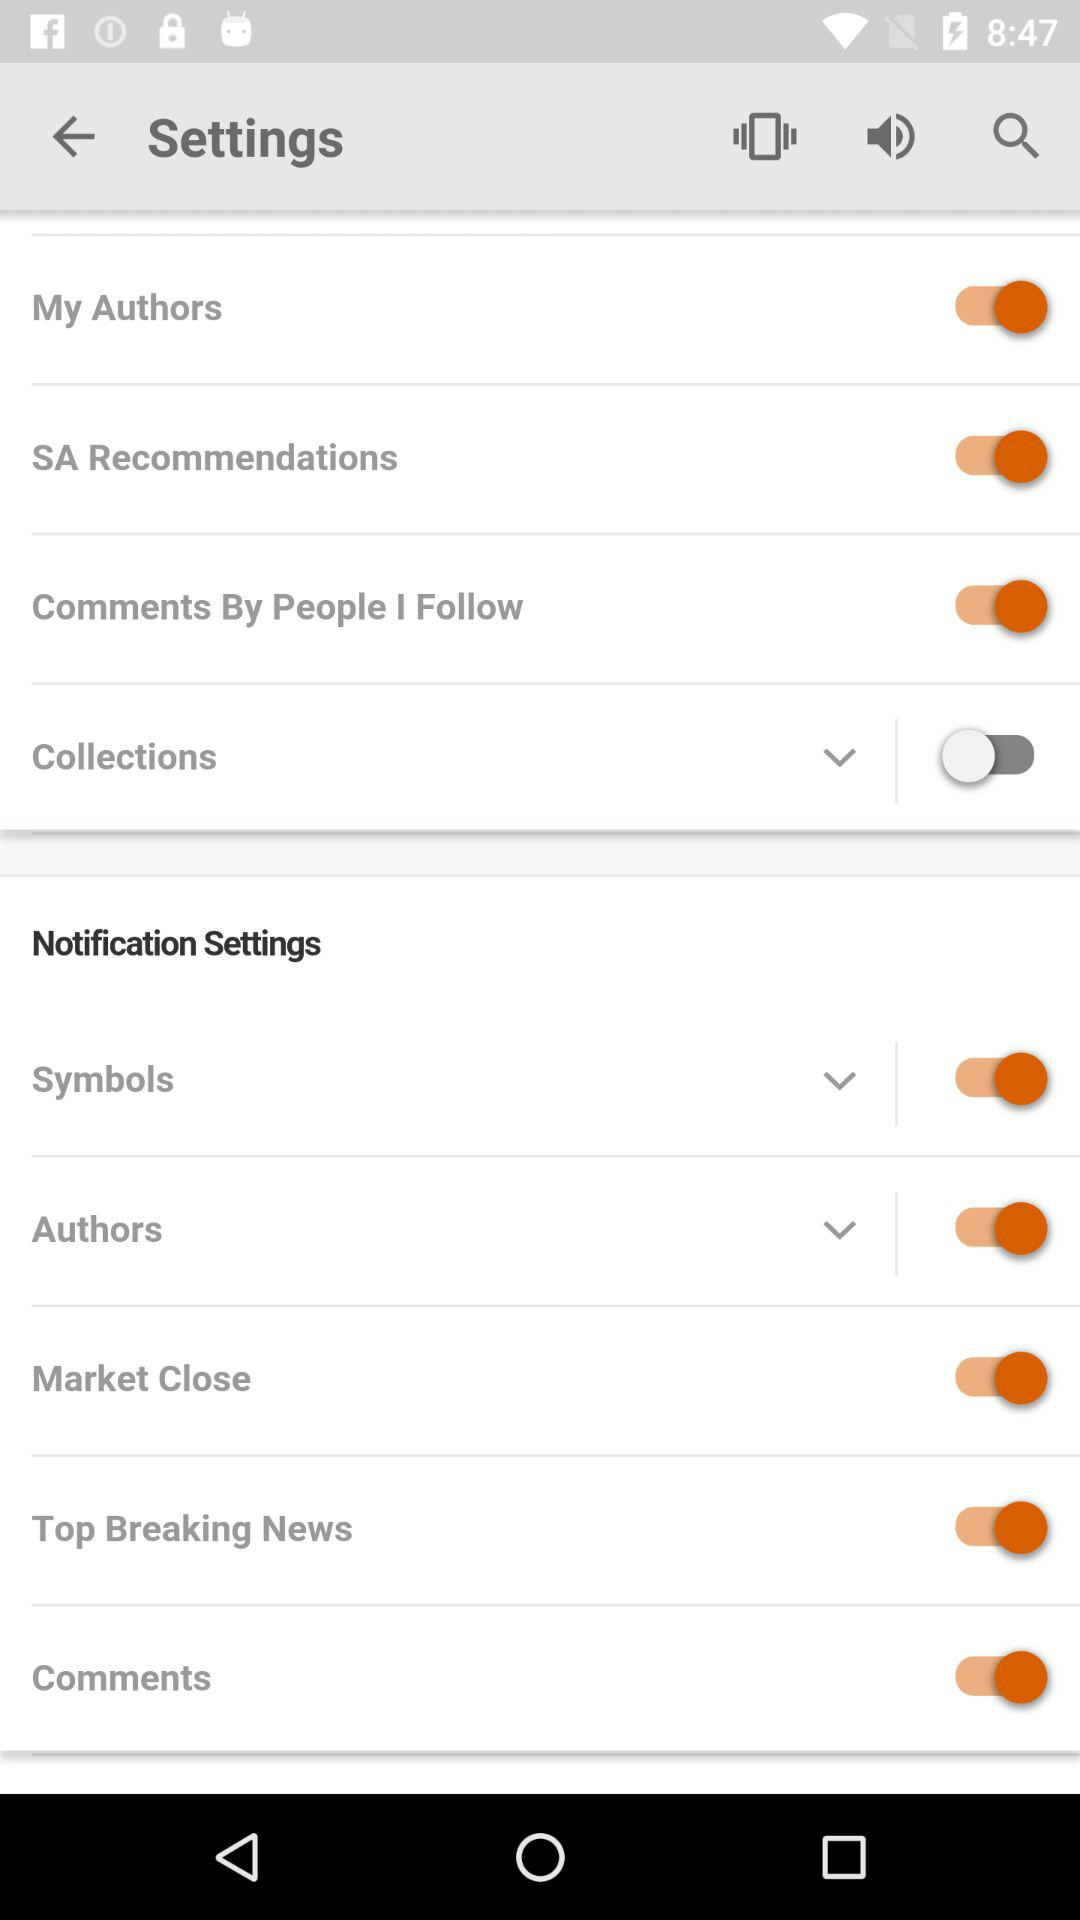What is the status of "Collections"? The status is "off". 